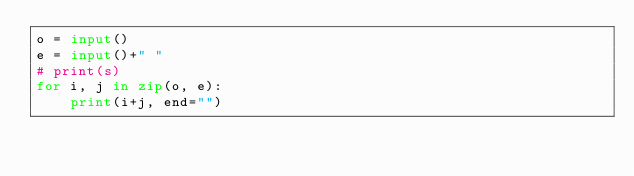<code> <loc_0><loc_0><loc_500><loc_500><_Python_>o = input()
e = input()+" "
# print(s)
for i, j in zip(o, e):
    print(i+j, end="")</code> 